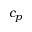Convert formula to latex. <formula><loc_0><loc_0><loc_500><loc_500>c _ { p }</formula> 